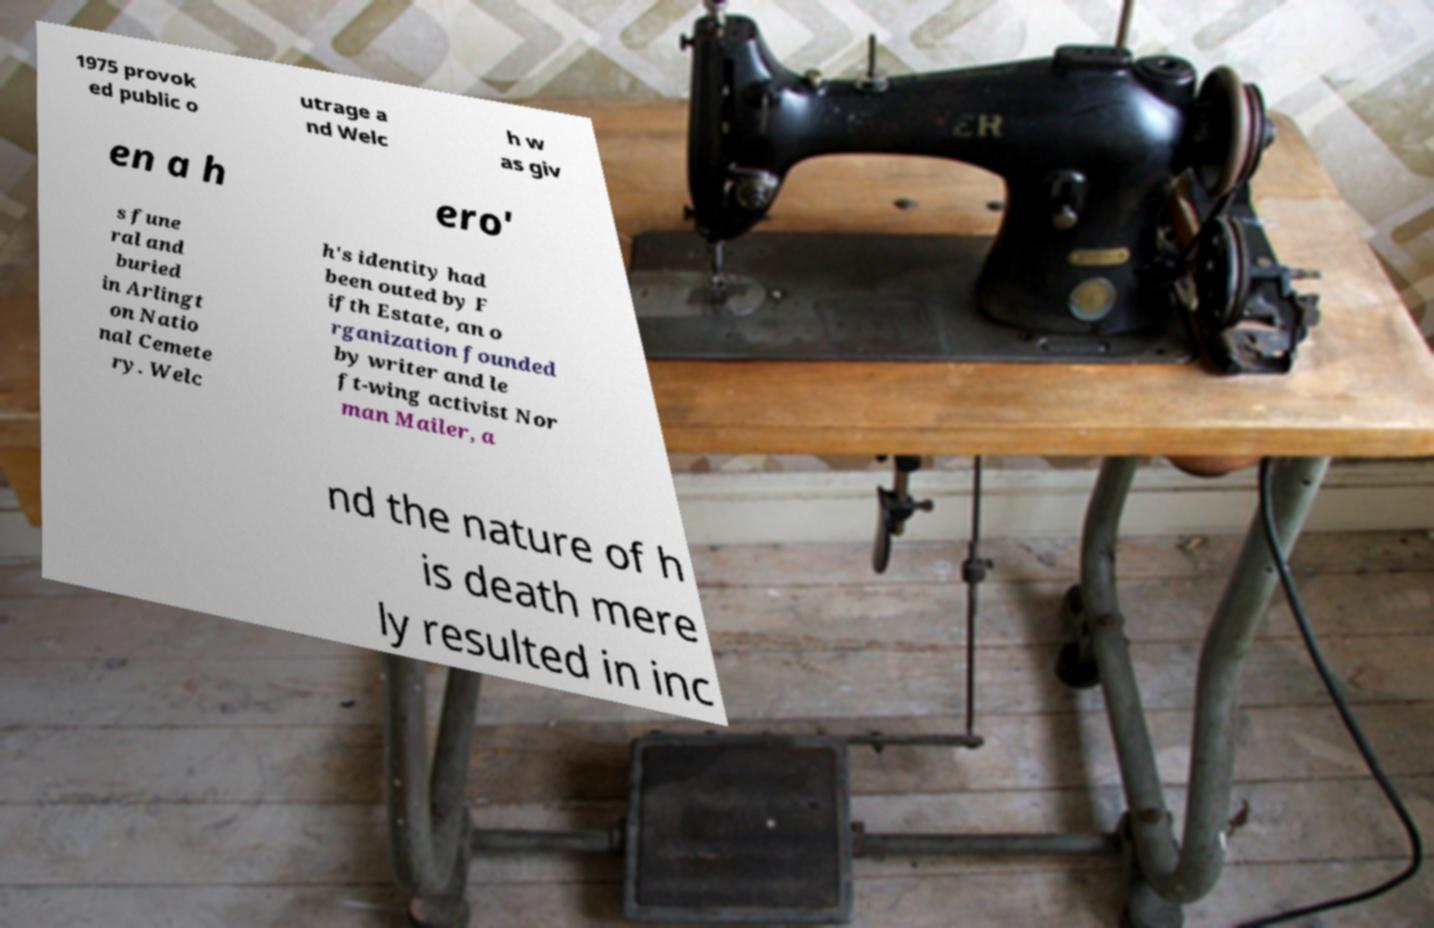Can you read and provide the text displayed in the image?This photo seems to have some interesting text. Can you extract and type it out for me? 1975 provok ed public o utrage a nd Welc h w as giv en a h ero' s fune ral and buried in Arlingt on Natio nal Cemete ry. Welc h's identity had been outed by F ifth Estate, an o rganization founded by writer and le ft-wing activist Nor man Mailer, a nd the nature of h is death mere ly resulted in inc 